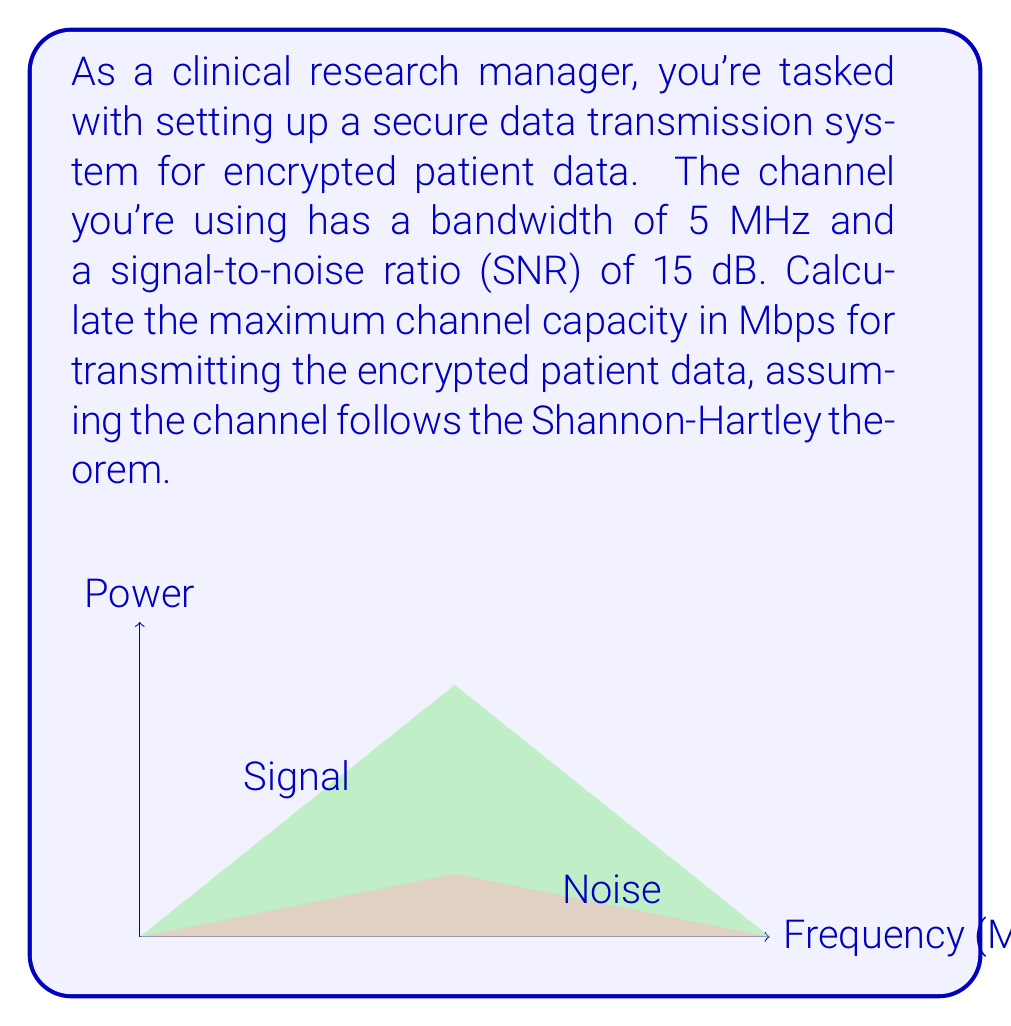Solve this math problem. To solve this problem, we'll use the Shannon-Hartley theorem, which gives the channel capacity for a noisy communication channel. The steps are as follows:

1) The Shannon-Hartley theorem states that the channel capacity $C$ is:

   $$C = B \log_2(1 + SNR)$$

   where $B$ is the bandwidth in Hz, and SNR is the signal-to-noise ratio.

2) We're given:
   - Bandwidth $B = 5$ MHz = $5 \times 10^6$ Hz
   - SNR = 15 dB

3) We need to convert the SNR from dB to a linear scale:
   
   $$SNR_{linear} = 10^{SNR_{dB}/10} = 10^{15/10} = 10^{1.5} \approx 31.6228$$

4) Now we can substitute these values into the Shannon-Hartley equation:

   $$C = (5 \times 10^6) \log_2(1 + 31.6228)$$

5) Calculate:
   
   $$C = (5 \times 10^6) \log_2(32.6228)$$
   $$C = (5 \times 10^6) (5.0279)$$
   $$C = 25.1395 \times 10^6 \text{ bits per second}$$

6) Convert to Mbps:
   
   $$C = 25.1395 \text{ Mbps}$$

Thus, the maximum channel capacity for transmitting encrypted patient data is approximately 25.1395 Mbps.
Answer: 25.1395 Mbps 